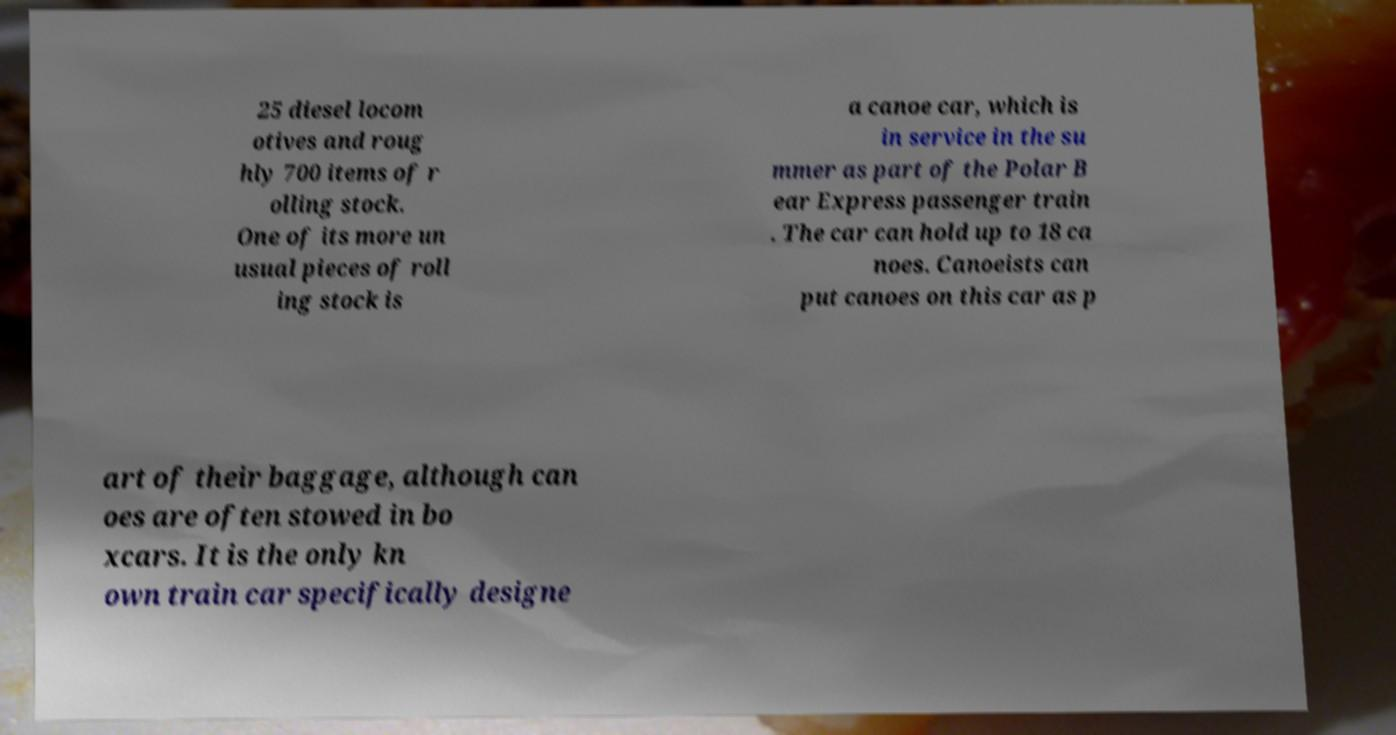Can you read and provide the text displayed in the image?This photo seems to have some interesting text. Can you extract and type it out for me? 25 diesel locom otives and roug hly 700 items of r olling stock. One of its more un usual pieces of roll ing stock is a canoe car, which is in service in the su mmer as part of the Polar B ear Express passenger train . The car can hold up to 18 ca noes. Canoeists can put canoes on this car as p art of their baggage, although can oes are often stowed in bo xcars. It is the only kn own train car specifically designe 